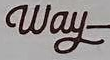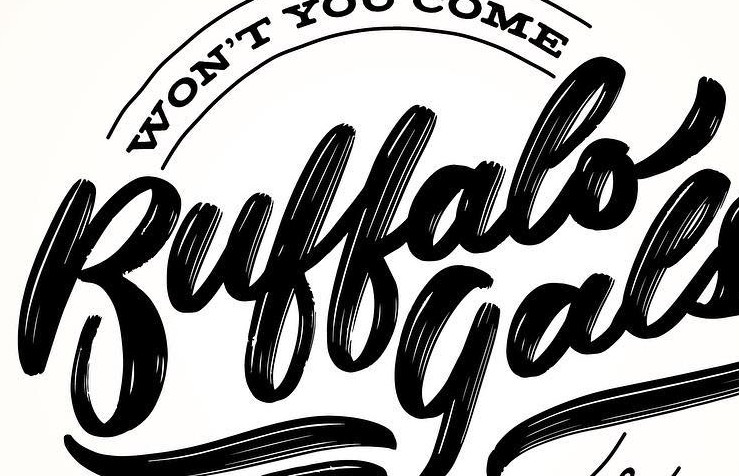Transcribe the words shown in these images in order, separated by a semicolon. Way; Buffalo 